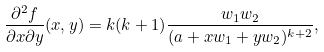Convert formula to latex. <formula><loc_0><loc_0><loc_500><loc_500>\frac { \partial ^ { 2 } f } { \partial x \partial y } ( x , y ) = k ( k + 1 ) \frac { w _ { 1 } w _ { 2 } } { ( a + x w _ { 1 } + y w _ { 2 } ) ^ { k + 2 } } ,</formula> 